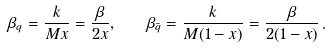<formula> <loc_0><loc_0><loc_500><loc_500>\beta _ { q } = \frac { k } { M x } = \frac { \beta } { 2 x } , \quad \beta _ { \bar { q } } = \frac { k } { M ( 1 - x ) } = \frac { \beta } { 2 ( 1 - x ) } \, .</formula> 